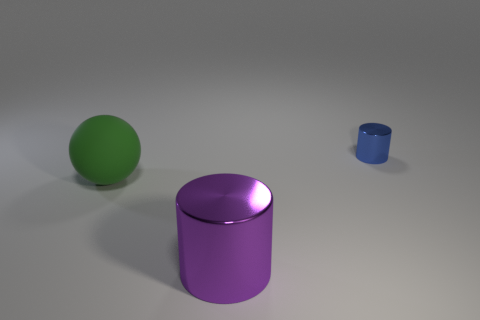What is the color of the object that is to the right of the big green thing and behind the large purple metallic thing?
Your answer should be very brief. Blue. Does the object in front of the matte thing have the same material as the big green sphere?
Your answer should be compact. No. There is a large shiny object; is its color the same as the object behind the big ball?
Your response must be concise. No. Are there any purple cylinders behind the small cylinder?
Give a very brief answer. No. Do the metallic thing in front of the green matte thing and the object to the right of the large purple metal thing have the same size?
Make the answer very short. No. Is there a purple cylinder of the same size as the blue thing?
Offer a terse response. No. Does the object to the left of the large purple thing have the same shape as the small blue object?
Offer a terse response. No. There is a thing behind the rubber thing; what material is it?
Your answer should be very brief. Metal. There is a metallic thing that is left of the metal cylinder behind the large purple shiny object; what shape is it?
Ensure brevity in your answer.  Cylinder. There is a matte thing; is it the same shape as the large thing to the right of the green rubber sphere?
Your response must be concise. No. 